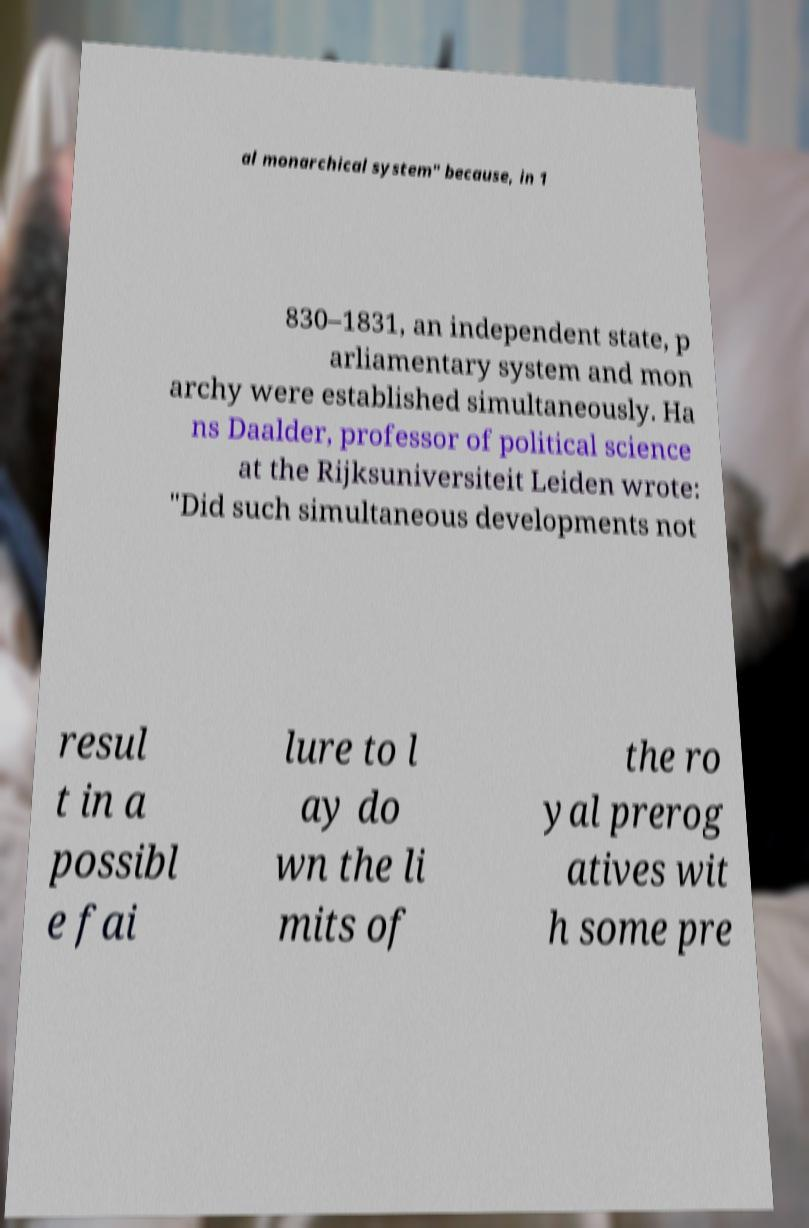For documentation purposes, I need the text within this image transcribed. Could you provide that? al monarchical system" because, in 1 830–1831, an independent state, p arliamentary system and mon archy were established simultaneously. Ha ns Daalder, professor of political science at the Rijksuniversiteit Leiden wrote: "Did such simultaneous developments not resul t in a possibl e fai lure to l ay do wn the li mits of the ro yal prerog atives wit h some pre 